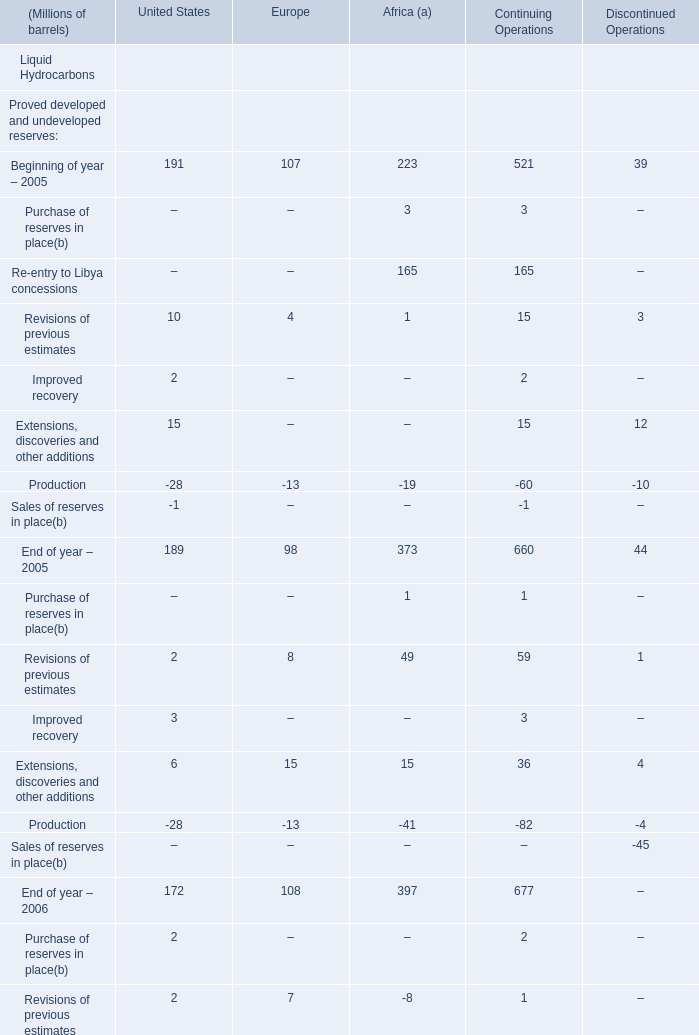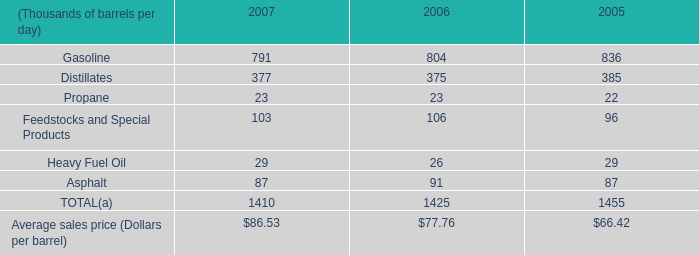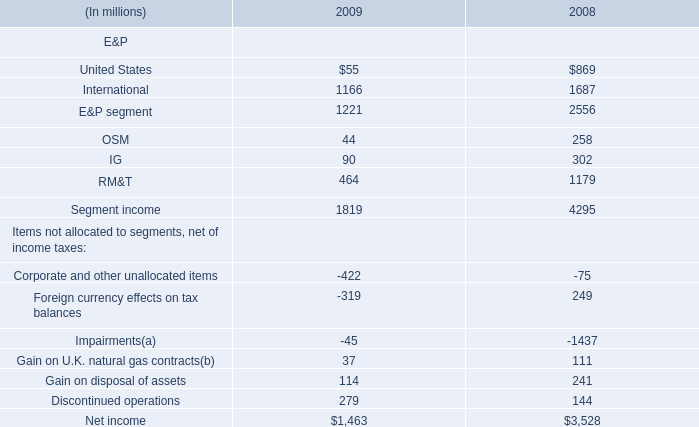what was three year total propane production in mmboe? 
Computations: ((23 + 23) + 22)
Answer: 68.0. 